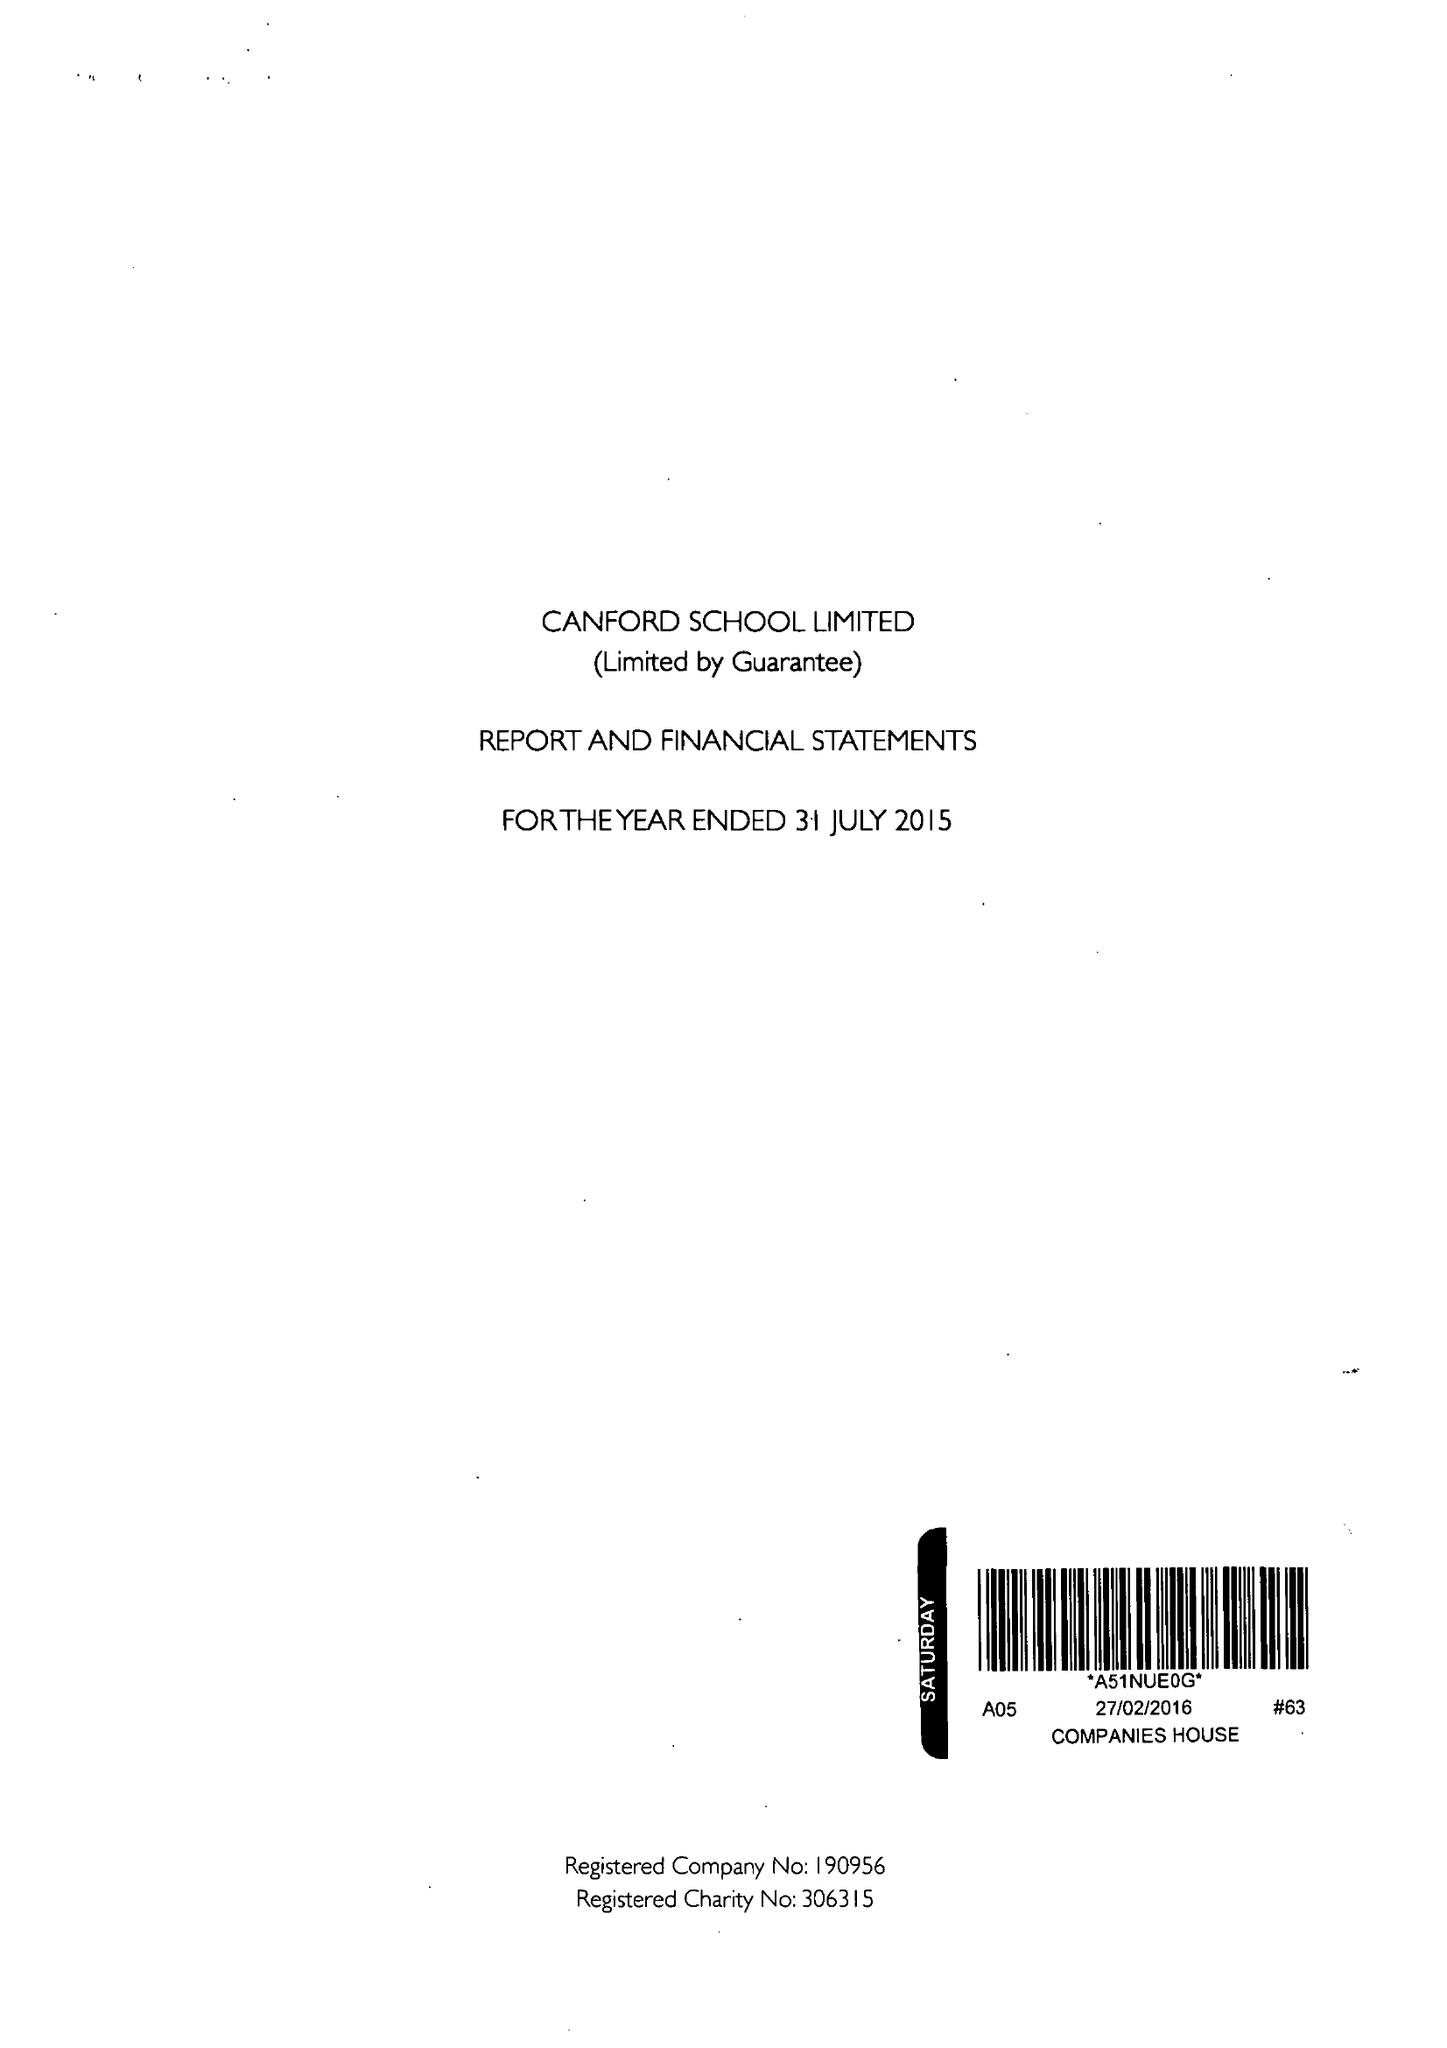What is the value for the charity_number?
Answer the question using a single word or phrase. 306315 